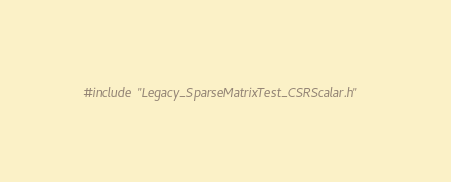Convert code to text. <code><loc_0><loc_0><loc_500><loc_500><_Cuda_>#include "Legacy_SparseMatrixTest_CSRScalar.h"
</code> 